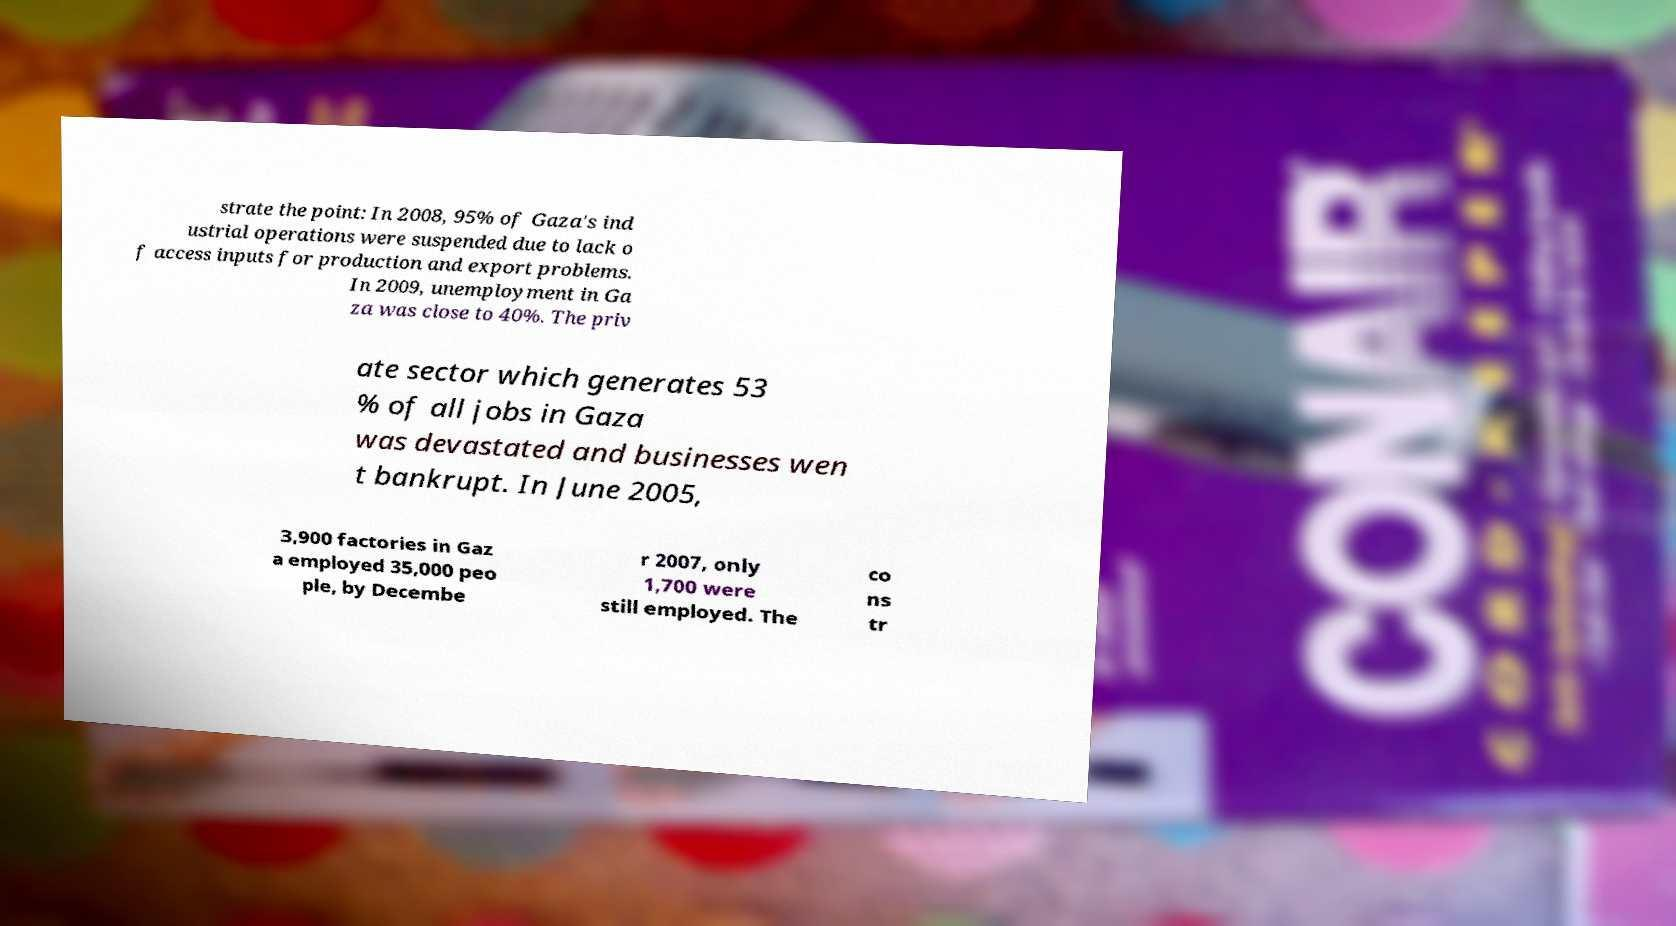Please identify and transcribe the text found in this image. strate the point: In 2008, 95% of Gaza's ind ustrial operations were suspended due to lack o f access inputs for production and export problems. In 2009, unemployment in Ga za was close to 40%. The priv ate sector which generates 53 % of all jobs in Gaza was devastated and businesses wen t bankrupt. In June 2005, 3,900 factories in Gaz a employed 35,000 peo ple, by Decembe r 2007, only 1,700 were still employed. The co ns tr 